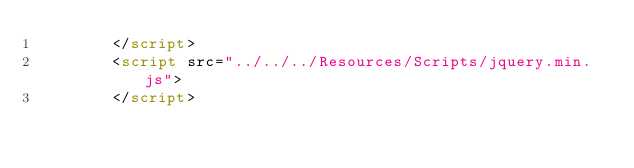Convert code to text. <code><loc_0><loc_0><loc_500><loc_500><_HTML_>        </script>
        <script src="../../../Resources/Scripts/jquery.min.js">
        </script></code> 